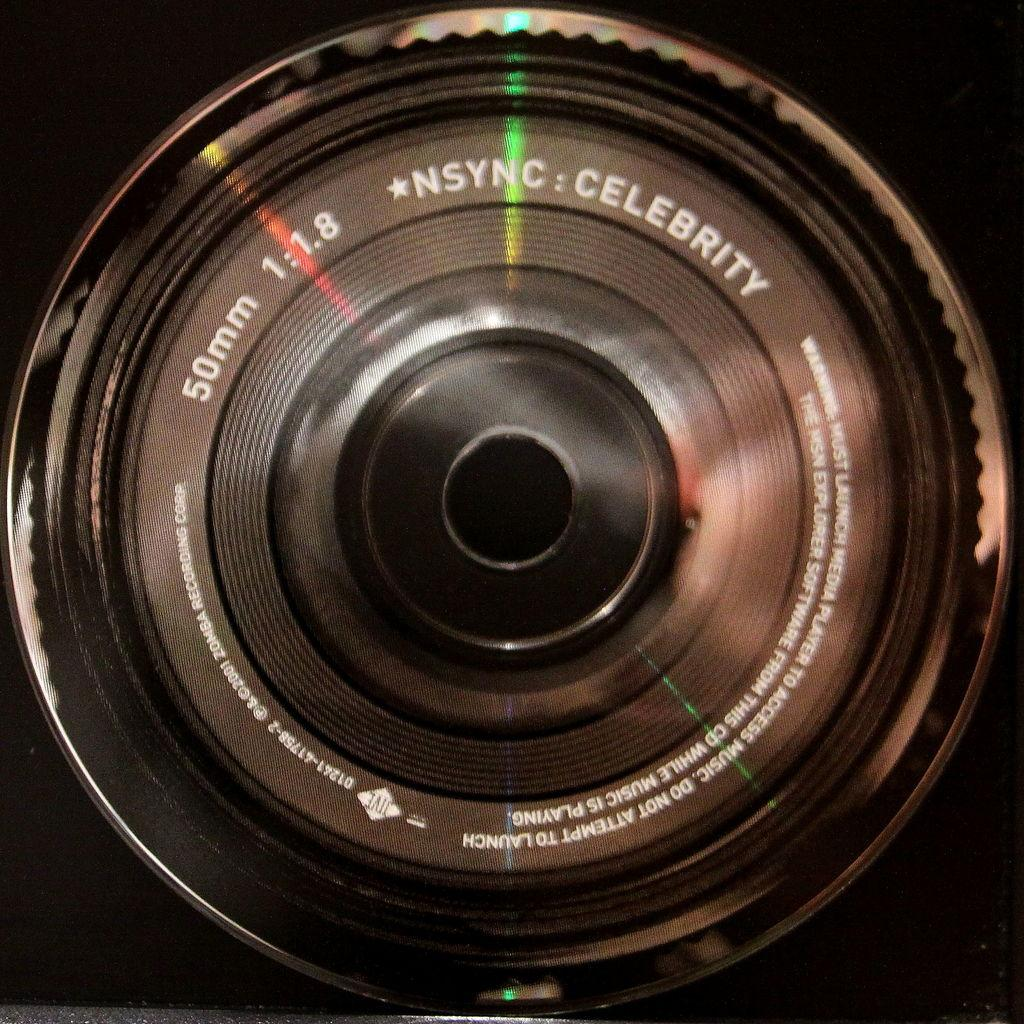What is the main subject of the image? The main subject of the image is a camera lens. What color is the background of the image? The background of the image is black. What type of amusement can be seen in the image? There is no amusement present in the image; it features a camera lens against a black background. What kind of connection is visible between the camera lens and the background? There is no visible connection between the camera lens and the background; the camera lens is simply placed against the black background. 